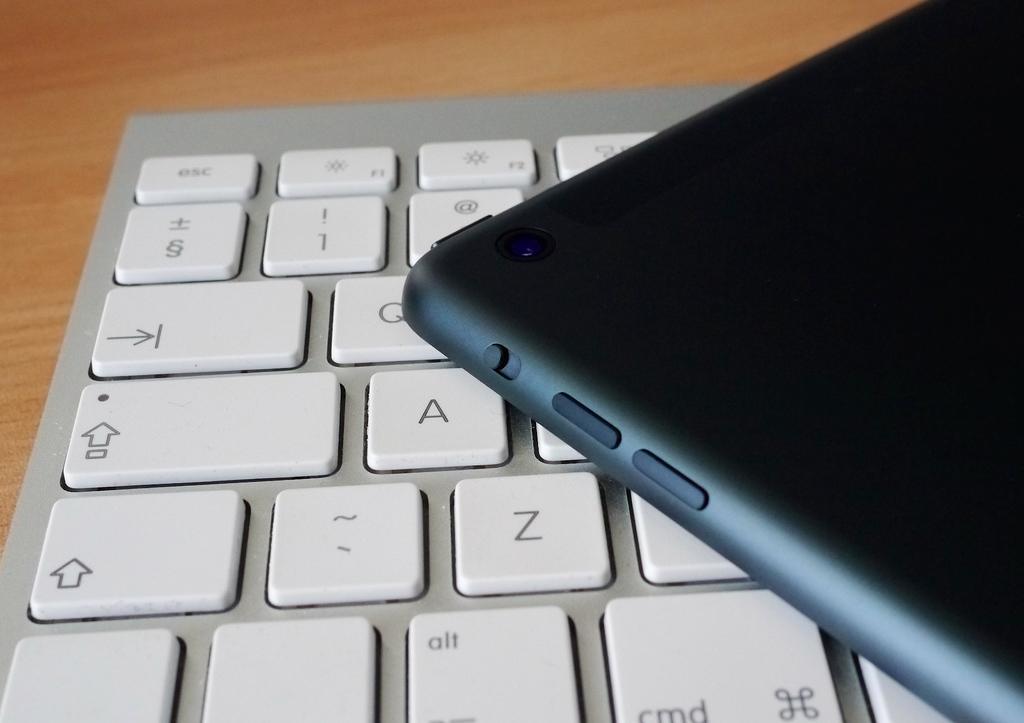How many capital letters can you clearly see?
Provide a short and direct response. 3. 